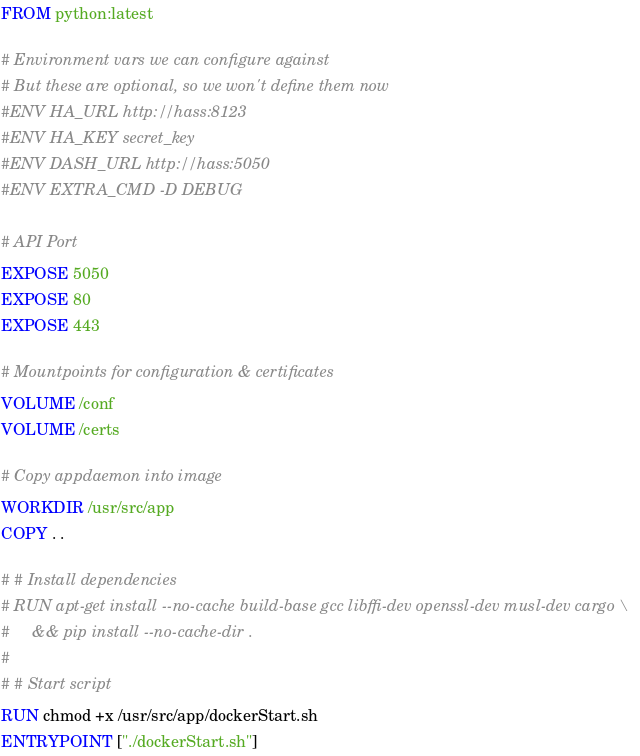Convert code to text. <code><loc_0><loc_0><loc_500><loc_500><_Dockerfile_>FROM python:latest

# Environment vars we can configure against
# But these are optional, so we won't define them now
#ENV HA_URL http://hass:8123
#ENV HA_KEY secret_key
#ENV DASH_URL http://hass:5050
#ENV EXTRA_CMD -D DEBUG

# API Port
EXPOSE 5050
EXPOSE 80
EXPOSE 443

# Mountpoints for configuration & certificates
VOLUME /conf
VOLUME /certs

# Copy appdaemon into image
WORKDIR /usr/src/app
COPY . .

# # Install dependencies
# RUN apt-get install --no-cache build-base gcc libffi-dev openssl-dev musl-dev cargo \
#     && pip install --no-cache-dir .
#
# # Start script
RUN chmod +x /usr/src/app/dockerStart.sh
ENTRYPOINT ["./dockerStart.sh"]
</code> 